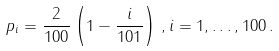Convert formula to latex. <formula><loc_0><loc_0><loc_500><loc_500>p _ { i } = \frac { 2 } { 1 0 0 } \left ( 1 - \frac { i } { 1 0 1 } \right ) \, , i = 1 , \dots , 1 0 0 \, .</formula> 